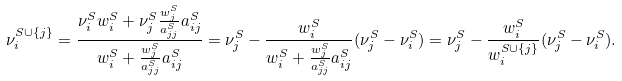<formula> <loc_0><loc_0><loc_500><loc_500>\nu _ { i } ^ { S \cup \{ j \} } & = \frac { \nu _ { i } ^ { S } w _ { i } ^ { S } + \nu _ { j } ^ { S } \frac { w _ { j } ^ { S } } { a _ { j j } ^ { S } } a _ { i j } ^ { S } } { w _ { i } ^ { S } + \frac { w _ { j } ^ { S } } { a _ { j j } ^ { S } } a _ { i j } ^ { S } } = \nu _ { j } ^ { S } - \frac { w _ { i } ^ { S } } { w _ { i } ^ { S } + \frac { w _ { j } ^ { S } } { a _ { j j } ^ { S } } a _ { i j } ^ { S } } ( \nu _ { j } ^ { S } - \nu _ { i } ^ { S } ) = \nu _ { j } ^ { S } - \frac { w _ { i } ^ { S } } { w _ { i } ^ { S \cup \{ j \} } } ( \nu _ { j } ^ { S } - \nu _ { i } ^ { S } ) .</formula> 